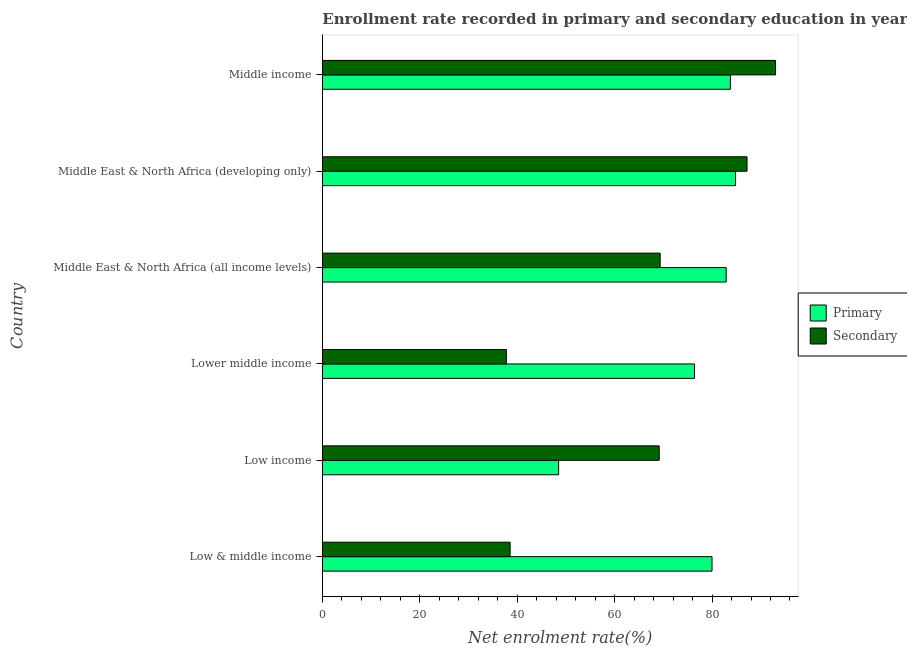Are the number of bars per tick equal to the number of legend labels?
Your answer should be compact. Yes. Are the number of bars on each tick of the Y-axis equal?
Keep it short and to the point. Yes. How many bars are there on the 5th tick from the top?
Give a very brief answer. 2. How many bars are there on the 6th tick from the bottom?
Give a very brief answer. 2. What is the label of the 3rd group of bars from the top?
Offer a terse response. Middle East & North Africa (all income levels). What is the enrollment rate in secondary education in Middle East & North Africa (developing only)?
Ensure brevity in your answer.  87.19. Across all countries, what is the maximum enrollment rate in primary education?
Give a very brief answer. 84.83. Across all countries, what is the minimum enrollment rate in primary education?
Ensure brevity in your answer.  48.51. In which country was the enrollment rate in primary education maximum?
Your response must be concise. Middle East & North Africa (developing only). In which country was the enrollment rate in primary education minimum?
Your answer should be very brief. Low income. What is the total enrollment rate in secondary education in the graph?
Your answer should be very brief. 395.06. What is the difference between the enrollment rate in secondary education in Low & middle income and that in Middle East & North Africa (all income levels)?
Offer a very short reply. -30.8. What is the difference between the enrollment rate in primary education in Middle East & North Africa (all income levels) and the enrollment rate in secondary education in Middle East & North Africa (developing only)?
Your answer should be very brief. -4.28. What is the average enrollment rate in secondary education per country?
Your answer should be very brief. 65.84. What is the difference between the enrollment rate in primary education and enrollment rate in secondary education in Lower middle income?
Your response must be concise. 38.63. In how many countries, is the enrollment rate in secondary education greater than 72 %?
Your answer should be very brief. 2. What is the ratio of the enrollment rate in secondary education in Middle East & North Africa (all income levels) to that in Middle East & North Africa (developing only)?
Offer a very short reply. 0.8. Is the enrollment rate in secondary education in Low income less than that in Middle East & North Africa (all income levels)?
Provide a succinct answer. Yes. What is the difference between the highest and the second highest enrollment rate in secondary education?
Offer a terse response. 5.85. What is the difference between the highest and the lowest enrollment rate in primary education?
Provide a short and direct response. 36.32. Is the sum of the enrollment rate in secondary education in Low & middle income and Middle East & North Africa (developing only) greater than the maximum enrollment rate in primary education across all countries?
Your answer should be very brief. Yes. What does the 2nd bar from the top in Middle East & North Africa (all income levels) represents?
Offer a very short reply. Primary. What does the 2nd bar from the bottom in Middle East & North Africa (developing only) represents?
Your response must be concise. Secondary. Are all the bars in the graph horizontal?
Your answer should be very brief. Yes. How many countries are there in the graph?
Your response must be concise. 6. Does the graph contain grids?
Provide a succinct answer. No. How are the legend labels stacked?
Provide a succinct answer. Vertical. What is the title of the graph?
Keep it short and to the point. Enrollment rate recorded in primary and secondary education in year 1991. Does "Highest 20% of population" appear as one of the legend labels in the graph?
Make the answer very short. No. What is the label or title of the X-axis?
Keep it short and to the point. Net enrolment rate(%). What is the Net enrolment rate(%) in Primary in Low & middle income?
Your answer should be very brief. 80. What is the Net enrolment rate(%) in Secondary in Low & middle income?
Provide a short and direct response. 38.55. What is the Net enrolment rate(%) of Primary in Low income?
Ensure brevity in your answer.  48.51. What is the Net enrolment rate(%) of Secondary in Low income?
Make the answer very short. 69.16. What is the Net enrolment rate(%) in Primary in Lower middle income?
Ensure brevity in your answer.  76.41. What is the Net enrolment rate(%) in Secondary in Lower middle income?
Your answer should be very brief. 37.77. What is the Net enrolment rate(%) in Primary in Middle East & North Africa (all income levels)?
Your response must be concise. 82.91. What is the Net enrolment rate(%) in Secondary in Middle East & North Africa (all income levels)?
Provide a short and direct response. 69.35. What is the Net enrolment rate(%) in Primary in Middle East & North Africa (developing only)?
Offer a very short reply. 84.83. What is the Net enrolment rate(%) in Secondary in Middle East & North Africa (developing only)?
Offer a terse response. 87.19. What is the Net enrolment rate(%) in Primary in Middle income?
Your answer should be compact. 83.77. What is the Net enrolment rate(%) in Secondary in Middle income?
Ensure brevity in your answer.  93.04. Across all countries, what is the maximum Net enrolment rate(%) in Primary?
Keep it short and to the point. 84.83. Across all countries, what is the maximum Net enrolment rate(%) of Secondary?
Your answer should be very brief. 93.04. Across all countries, what is the minimum Net enrolment rate(%) in Primary?
Your answer should be compact. 48.51. Across all countries, what is the minimum Net enrolment rate(%) in Secondary?
Your answer should be very brief. 37.77. What is the total Net enrolment rate(%) of Primary in the graph?
Your answer should be very brief. 456.41. What is the total Net enrolment rate(%) of Secondary in the graph?
Give a very brief answer. 395.06. What is the difference between the Net enrolment rate(%) of Primary in Low & middle income and that in Low income?
Make the answer very short. 31.49. What is the difference between the Net enrolment rate(%) in Secondary in Low & middle income and that in Low income?
Make the answer very short. -30.61. What is the difference between the Net enrolment rate(%) of Primary in Low & middle income and that in Lower middle income?
Your answer should be compact. 3.6. What is the difference between the Net enrolment rate(%) in Secondary in Low & middle income and that in Lower middle income?
Your answer should be very brief. 0.78. What is the difference between the Net enrolment rate(%) in Primary in Low & middle income and that in Middle East & North Africa (all income levels)?
Your answer should be very brief. -2.91. What is the difference between the Net enrolment rate(%) in Secondary in Low & middle income and that in Middle East & North Africa (all income levels)?
Your answer should be very brief. -30.8. What is the difference between the Net enrolment rate(%) in Primary in Low & middle income and that in Middle East & North Africa (developing only)?
Make the answer very short. -4.83. What is the difference between the Net enrolment rate(%) of Secondary in Low & middle income and that in Middle East & North Africa (developing only)?
Keep it short and to the point. -48.64. What is the difference between the Net enrolment rate(%) of Primary in Low & middle income and that in Middle income?
Your answer should be very brief. -3.76. What is the difference between the Net enrolment rate(%) of Secondary in Low & middle income and that in Middle income?
Your answer should be compact. -54.49. What is the difference between the Net enrolment rate(%) in Primary in Low income and that in Lower middle income?
Provide a short and direct response. -27.9. What is the difference between the Net enrolment rate(%) of Secondary in Low income and that in Lower middle income?
Provide a short and direct response. 31.39. What is the difference between the Net enrolment rate(%) of Primary in Low income and that in Middle East & North Africa (all income levels)?
Provide a succinct answer. -34.4. What is the difference between the Net enrolment rate(%) of Secondary in Low income and that in Middle East & North Africa (all income levels)?
Offer a very short reply. -0.19. What is the difference between the Net enrolment rate(%) of Primary in Low income and that in Middle East & North Africa (developing only)?
Make the answer very short. -36.32. What is the difference between the Net enrolment rate(%) in Secondary in Low income and that in Middle East & North Africa (developing only)?
Your answer should be compact. -18.03. What is the difference between the Net enrolment rate(%) of Primary in Low income and that in Middle income?
Ensure brevity in your answer.  -35.26. What is the difference between the Net enrolment rate(%) of Secondary in Low income and that in Middle income?
Offer a terse response. -23.88. What is the difference between the Net enrolment rate(%) in Primary in Lower middle income and that in Middle East & North Africa (all income levels)?
Ensure brevity in your answer.  -6.5. What is the difference between the Net enrolment rate(%) of Secondary in Lower middle income and that in Middle East & North Africa (all income levels)?
Make the answer very short. -31.58. What is the difference between the Net enrolment rate(%) of Primary in Lower middle income and that in Middle East & North Africa (developing only)?
Your answer should be compact. -8.42. What is the difference between the Net enrolment rate(%) in Secondary in Lower middle income and that in Middle East & North Africa (developing only)?
Offer a terse response. -49.42. What is the difference between the Net enrolment rate(%) in Primary in Lower middle income and that in Middle income?
Ensure brevity in your answer.  -7.36. What is the difference between the Net enrolment rate(%) of Secondary in Lower middle income and that in Middle income?
Give a very brief answer. -55.27. What is the difference between the Net enrolment rate(%) of Primary in Middle East & North Africa (all income levels) and that in Middle East & North Africa (developing only)?
Provide a succinct answer. -1.92. What is the difference between the Net enrolment rate(%) in Secondary in Middle East & North Africa (all income levels) and that in Middle East & North Africa (developing only)?
Give a very brief answer. -17.84. What is the difference between the Net enrolment rate(%) in Primary in Middle East & North Africa (all income levels) and that in Middle income?
Provide a short and direct response. -0.86. What is the difference between the Net enrolment rate(%) of Secondary in Middle East & North Africa (all income levels) and that in Middle income?
Keep it short and to the point. -23.69. What is the difference between the Net enrolment rate(%) of Primary in Middle East & North Africa (developing only) and that in Middle income?
Provide a short and direct response. 1.06. What is the difference between the Net enrolment rate(%) in Secondary in Middle East & North Africa (developing only) and that in Middle income?
Offer a very short reply. -5.85. What is the difference between the Net enrolment rate(%) in Primary in Low & middle income and the Net enrolment rate(%) in Secondary in Low income?
Provide a short and direct response. 10.84. What is the difference between the Net enrolment rate(%) in Primary in Low & middle income and the Net enrolment rate(%) in Secondary in Lower middle income?
Provide a succinct answer. 42.23. What is the difference between the Net enrolment rate(%) of Primary in Low & middle income and the Net enrolment rate(%) of Secondary in Middle East & North Africa (all income levels)?
Make the answer very short. 10.65. What is the difference between the Net enrolment rate(%) in Primary in Low & middle income and the Net enrolment rate(%) in Secondary in Middle East & North Africa (developing only)?
Your answer should be very brief. -7.19. What is the difference between the Net enrolment rate(%) in Primary in Low & middle income and the Net enrolment rate(%) in Secondary in Middle income?
Your response must be concise. -13.04. What is the difference between the Net enrolment rate(%) of Primary in Low income and the Net enrolment rate(%) of Secondary in Lower middle income?
Keep it short and to the point. 10.73. What is the difference between the Net enrolment rate(%) of Primary in Low income and the Net enrolment rate(%) of Secondary in Middle East & North Africa (all income levels)?
Keep it short and to the point. -20.84. What is the difference between the Net enrolment rate(%) in Primary in Low income and the Net enrolment rate(%) in Secondary in Middle East & North Africa (developing only)?
Your answer should be very brief. -38.68. What is the difference between the Net enrolment rate(%) in Primary in Low income and the Net enrolment rate(%) in Secondary in Middle income?
Provide a succinct answer. -44.53. What is the difference between the Net enrolment rate(%) in Primary in Lower middle income and the Net enrolment rate(%) in Secondary in Middle East & North Africa (all income levels)?
Make the answer very short. 7.05. What is the difference between the Net enrolment rate(%) of Primary in Lower middle income and the Net enrolment rate(%) of Secondary in Middle East & North Africa (developing only)?
Your answer should be very brief. -10.78. What is the difference between the Net enrolment rate(%) of Primary in Lower middle income and the Net enrolment rate(%) of Secondary in Middle income?
Offer a terse response. -16.64. What is the difference between the Net enrolment rate(%) of Primary in Middle East & North Africa (all income levels) and the Net enrolment rate(%) of Secondary in Middle East & North Africa (developing only)?
Your response must be concise. -4.28. What is the difference between the Net enrolment rate(%) in Primary in Middle East & North Africa (all income levels) and the Net enrolment rate(%) in Secondary in Middle income?
Give a very brief answer. -10.13. What is the difference between the Net enrolment rate(%) of Primary in Middle East & North Africa (developing only) and the Net enrolment rate(%) of Secondary in Middle income?
Provide a short and direct response. -8.21. What is the average Net enrolment rate(%) of Primary per country?
Ensure brevity in your answer.  76.07. What is the average Net enrolment rate(%) in Secondary per country?
Your answer should be compact. 65.84. What is the difference between the Net enrolment rate(%) of Primary and Net enrolment rate(%) of Secondary in Low & middle income?
Keep it short and to the point. 41.45. What is the difference between the Net enrolment rate(%) in Primary and Net enrolment rate(%) in Secondary in Low income?
Ensure brevity in your answer.  -20.65. What is the difference between the Net enrolment rate(%) in Primary and Net enrolment rate(%) in Secondary in Lower middle income?
Give a very brief answer. 38.63. What is the difference between the Net enrolment rate(%) in Primary and Net enrolment rate(%) in Secondary in Middle East & North Africa (all income levels)?
Offer a very short reply. 13.56. What is the difference between the Net enrolment rate(%) in Primary and Net enrolment rate(%) in Secondary in Middle East & North Africa (developing only)?
Provide a succinct answer. -2.36. What is the difference between the Net enrolment rate(%) in Primary and Net enrolment rate(%) in Secondary in Middle income?
Your answer should be compact. -9.27. What is the ratio of the Net enrolment rate(%) in Primary in Low & middle income to that in Low income?
Make the answer very short. 1.65. What is the ratio of the Net enrolment rate(%) in Secondary in Low & middle income to that in Low income?
Offer a terse response. 0.56. What is the ratio of the Net enrolment rate(%) of Primary in Low & middle income to that in Lower middle income?
Your answer should be compact. 1.05. What is the ratio of the Net enrolment rate(%) in Secondary in Low & middle income to that in Lower middle income?
Your answer should be very brief. 1.02. What is the ratio of the Net enrolment rate(%) in Primary in Low & middle income to that in Middle East & North Africa (all income levels)?
Give a very brief answer. 0.96. What is the ratio of the Net enrolment rate(%) in Secondary in Low & middle income to that in Middle East & North Africa (all income levels)?
Keep it short and to the point. 0.56. What is the ratio of the Net enrolment rate(%) in Primary in Low & middle income to that in Middle East & North Africa (developing only)?
Your response must be concise. 0.94. What is the ratio of the Net enrolment rate(%) in Secondary in Low & middle income to that in Middle East & North Africa (developing only)?
Your answer should be very brief. 0.44. What is the ratio of the Net enrolment rate(%) of Primary in Low & middle income to that in Middle income?
Ensure brevity in your answer.  0.96. What is the ratio of the Net enrolment rate(%) of Secondary in Low & middle income to that in Middle income?
Offer a terse response. 0.41. What is the ratio of the Net enrolment rate(%) of Primary in Low income to that in Lower middle income?
Your answer should be very brief. 0.63. What is the ratio of the Net enrolment rate(%) in Secondary in Low income to that in Lower middle income?
Your answer should be very brief. 1.83. What is the ratio of the Net enrolment rate(%) in Primary in Low income to that in Middle East & North Africa (all income levels)?
Your answer should be compact. 0.59. What is the ratio of the Net enrolment rate(%) in Secondary in Low income to that in Middle East & North Africa (all income levels)?
Offer a very short reply. 1. What is the ratio of the Net enrolment rate(%) of Primary in Low income to that in Middle East & North Africa (developing only)?
Provide a short and direct response. 0.57. What is the ratio of the Net enrolment rate(%) in Secondary in Low income to that in Middle East & North Africa (developing only)?
Your answer should be compact. 0.79. What is the ratio of the Net enrolment rate(%) of Primary in Low income to that in Middle income?
Provide a succinct answer. 0.58. What is the ratio of the Net enrolment rate(%) of Secondary in Low income to that in Middle income?
Make the answer very short. 0.74. What is the ratio of the Net enrolment rate(%) in Primary in Lower middle income to that in Middle East & North Africa (all income levels)?
Your answer should be compact. 0.92. What is the ratio of the Net enrolment rate(%) in Secondary in Lower middle income to that in Middle East & North Africa (all income levels)?
Keep it short and to the point. 0.54. What is the ratio of the Net enrolment rate(%) in Primary in Lower middle income to that in Middle East & North Africa (developing only)?
Keep it short and to the point. 0.9. What is the ratio of the Net enrolment rate(%) of Secondary in Lower middle income to that in Middle East & North Africa (developing only)?
Ensure brevity in your answer.  0.43. What is the ratio of the Net enrolment rate(%) in Primary in Lower middle income to that in Middle income?
Your response must be concise. 0.91. What is the ratio of the Net enrolment rate(%) of Secondary in Lower middle income to that in Middle income?
Your answer should be very brief. 0.41. What is the ratio of the Net enrolment rate(%) of Primary in Middle East & North Africa (all income levels) to that in Middle East & North Africa (developing only)?
Give a very brief answer. 0.98. What is the ratio of the Net enrolment rate(%) of Secondary in Middle East & North Africa (all income levels) to that in Middle East & North Africa (developing only)?
Your answer should be very brief. 0.8. What is the ratio of the Net enrolment rate(%) of Secondary in Middle East & North Africa (all income levels) to that in Middle income?
Ensure brevity in your answer.  0.75. What is the ratio of the Net enrolment rate(%) of Primary in Middle East & North Africa (developing only) to that in Middle income?
Provide a succinct answer. 1.01. What is the ratio of the Net enrolment rate(%) of Secondary in Middle East & North Africa (developing only) to that in Middle income?
Give a very brief answer. 0.94. What is the difference between the highest and the second highest Net enrolment rate(%) in Primary?
Your answer should be very brief. 1.06. What is the difference between the highest and the second highest Net enrolment rate(%) of Secondary?
Offer a very short reply. 5.85. What is the difference between the highest and the lowest Net enrolment rate(%) of Primary?
Make the answer very short. 36.32. What is the difference between the highest and the lowest Net enrolment rate(%) of Secondary?
Give a very brief answer. 55.27. 